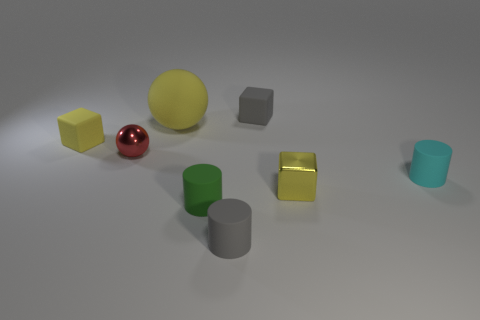Is the large rubber ball the same color as the tiny metal block?
Give a very brief answer. Yes. Is the yellow sphere that is behind the tiny cyan rubber cylinder made of the same material as the yellow block in front of the red metal thing?
Offer a very short reply. No. There is a gray cylinder that is made of the same material as the gray block; what is its size?
Your answer should be compact. Small. Is the number of rubber objects that are in front of the green rubber cylinder greater than the number of tiny spheres to the right of the yellow metal object?
Offer a terse response. Yes. Is there a cyan matte thing of the same shape as the green matte object?
Make the answer very short. Yes. There is a gray matte thing that is behind the yellow sphere; is its size the same as the tiny cyan matte object?
Your response must be concise. Yes. Are any large brown rubber objects visible?
Give a very brief answer. No. What number of objects are either tiny rubber blocks that are in front of the large yellow matte thing or matte balls?
Keep it short and to the point. 2. There is a big rubber sphere; is its color the same as the small shiny thing that is right of the red shiny thing?
Offer a very short reply. Yes. Is there a yellow object that has the same size as the yellow matte ball?
Provide a succinct answer. No. 